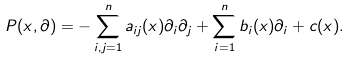Convert formula to latex. <formula><loc_0><loc_0><loc_500><loc_500>P ( x , \partial ) = - \sum _ { i , j = 1 } ^ { n } a _ { i j } ( x ) \partial _ { i } \partial _ { j } + \sum _ { i = 1 } ^ { n } b _ { i } ( x ) \partial _ { i } + c ( x ) .</formula> 